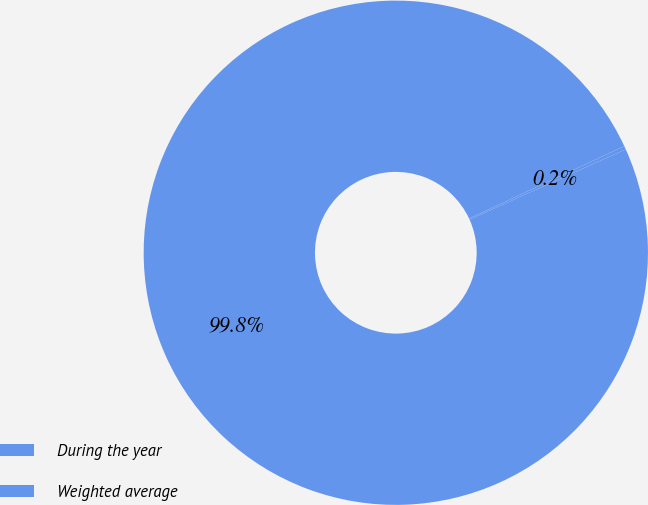Convert chart to OTSL. <chart><loc_0><loc_0><loc_500><loc_500><pie_chart><fcel>During the year<fcel>Weighted average<nl><fcel>99.78%<fcel>0.22%<nl></chart> 